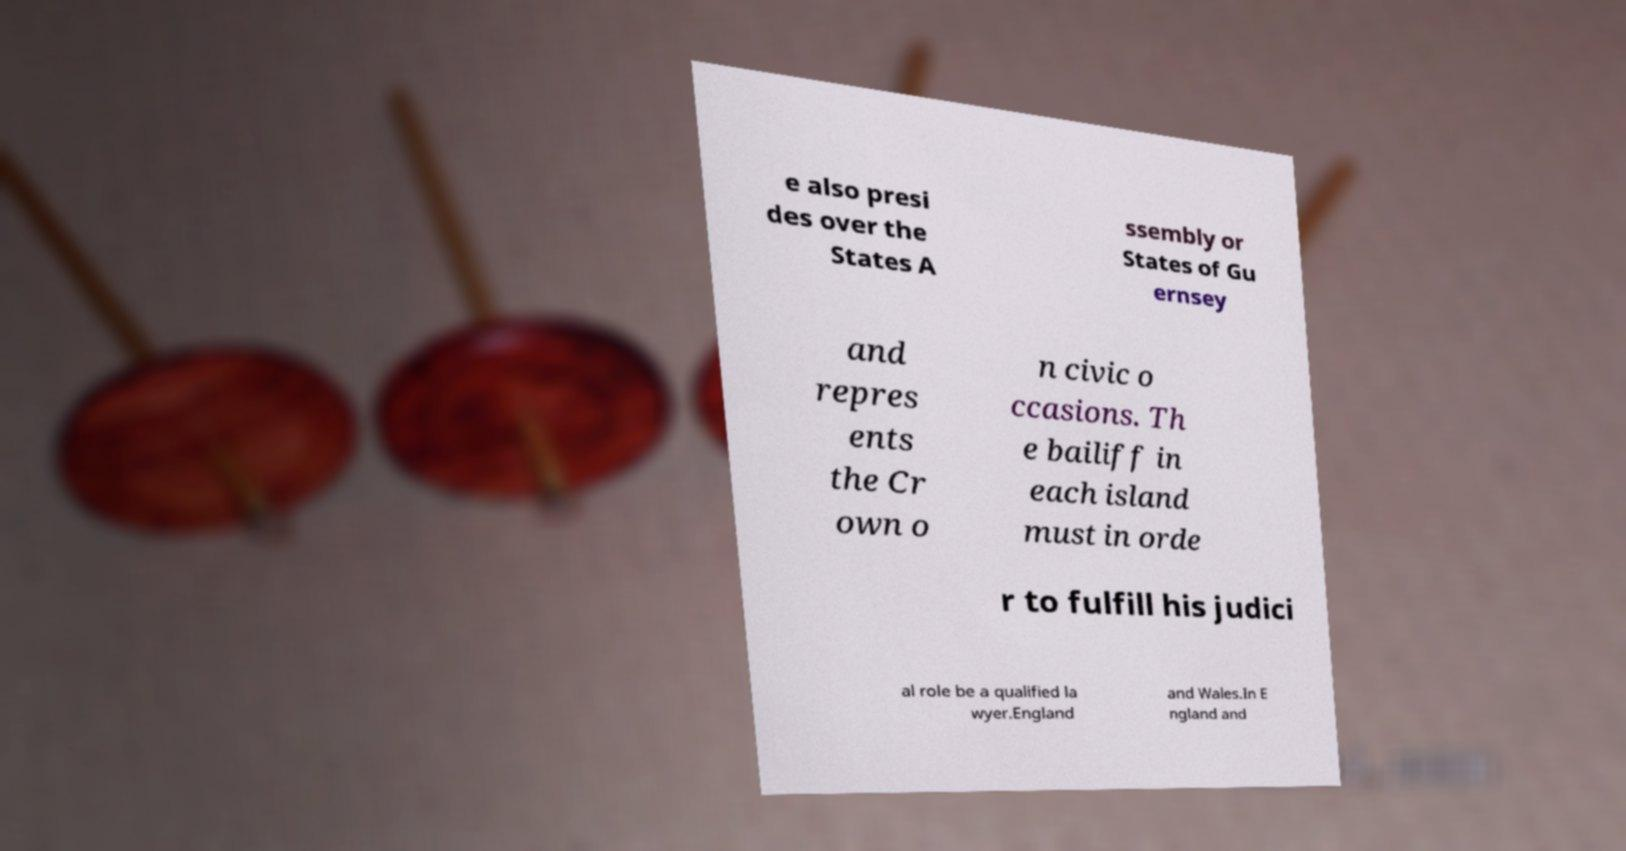Please identify and transcribe the text found in this image. e also presi des over the States A ssembly or States of Gu ernsey and repres ents the Cr own o n civic o ccasions. Th e bailiff in each island must in orde r to fulfill his judici al role be a qualified la wyer.England and Wales.In E ngland and 